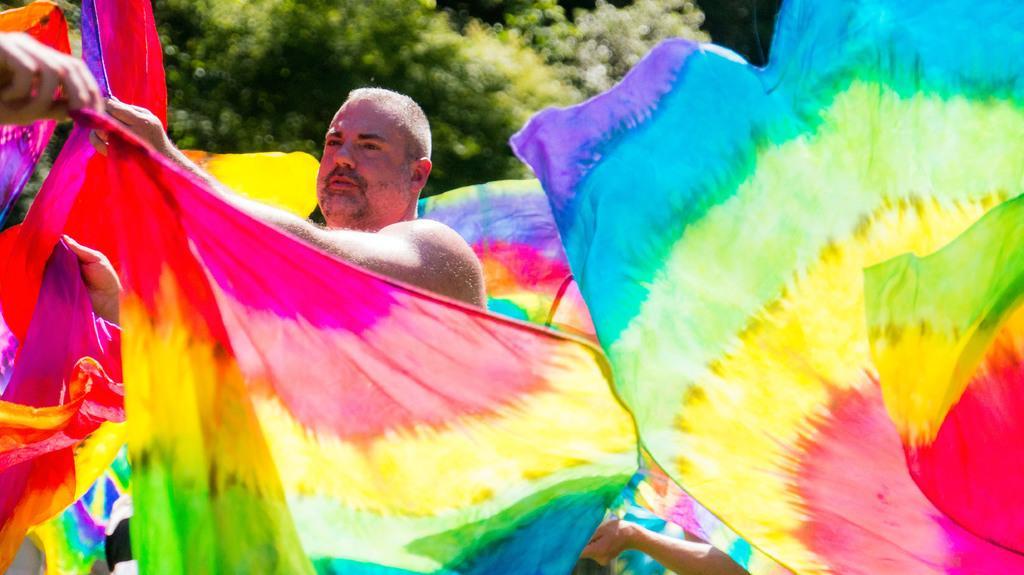Can you describe this image briefly? Here we can see a person and a rainbow color clothes. Far there is a tree. 